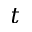<formula> <loc_0><loc_0><loc_500><loc_500>t</formula> 